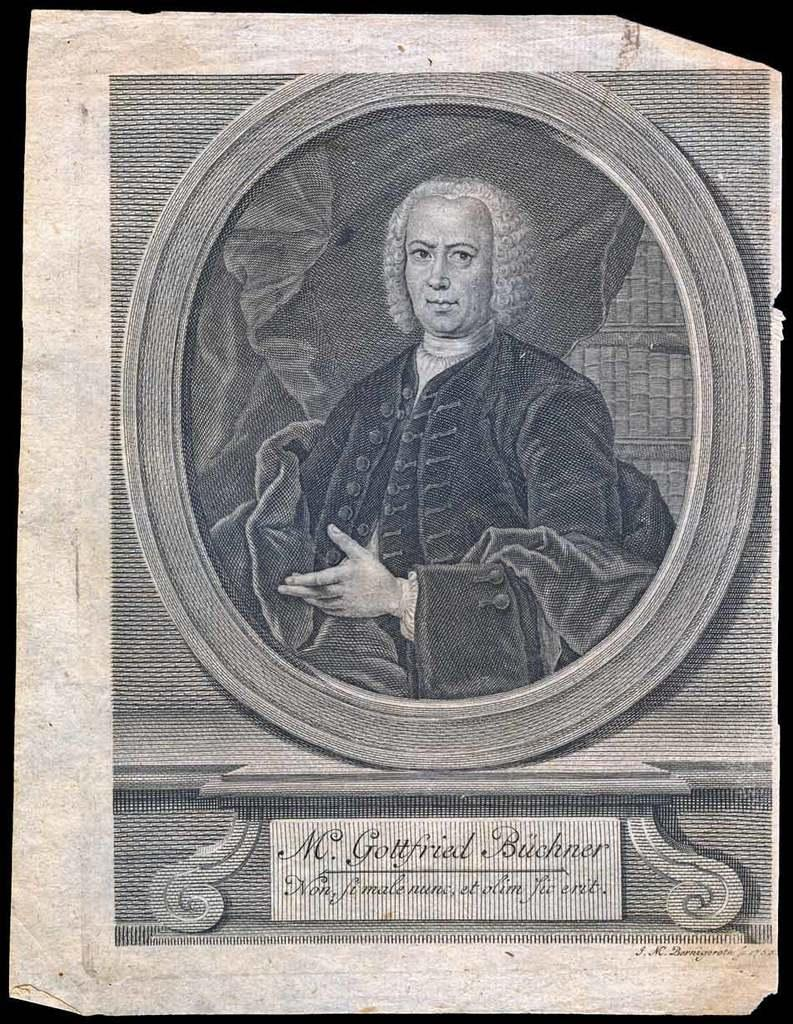What is the person in the image doing? The person is drawing. What is the person drawing on? The paper is placed on a black surface. What can be seen on the paper besides the drawing? There is a name board on the paper. What type of copper material is being used to create the bridge in the image? There is no bridge present in the image, and no mention of copper material. 